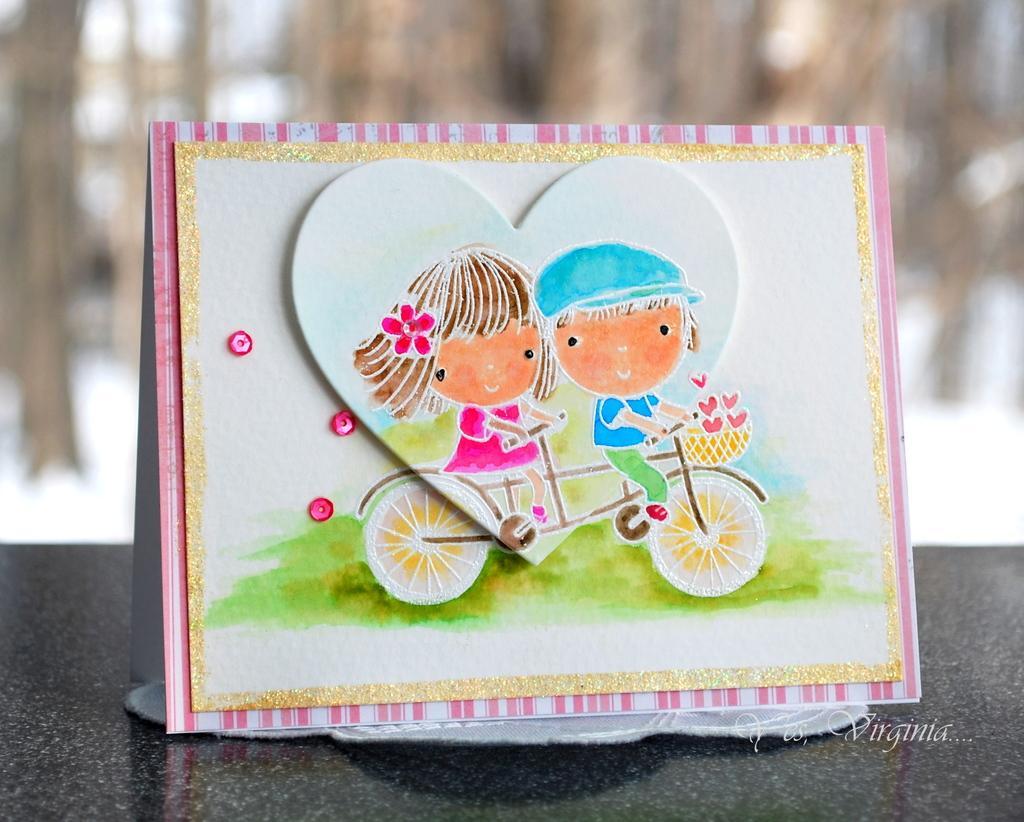Describe this image in one or two sentences. In this image there is a card, there is a painting on the card, there is text towards the bottom of the image, the background of the image is blurred. 